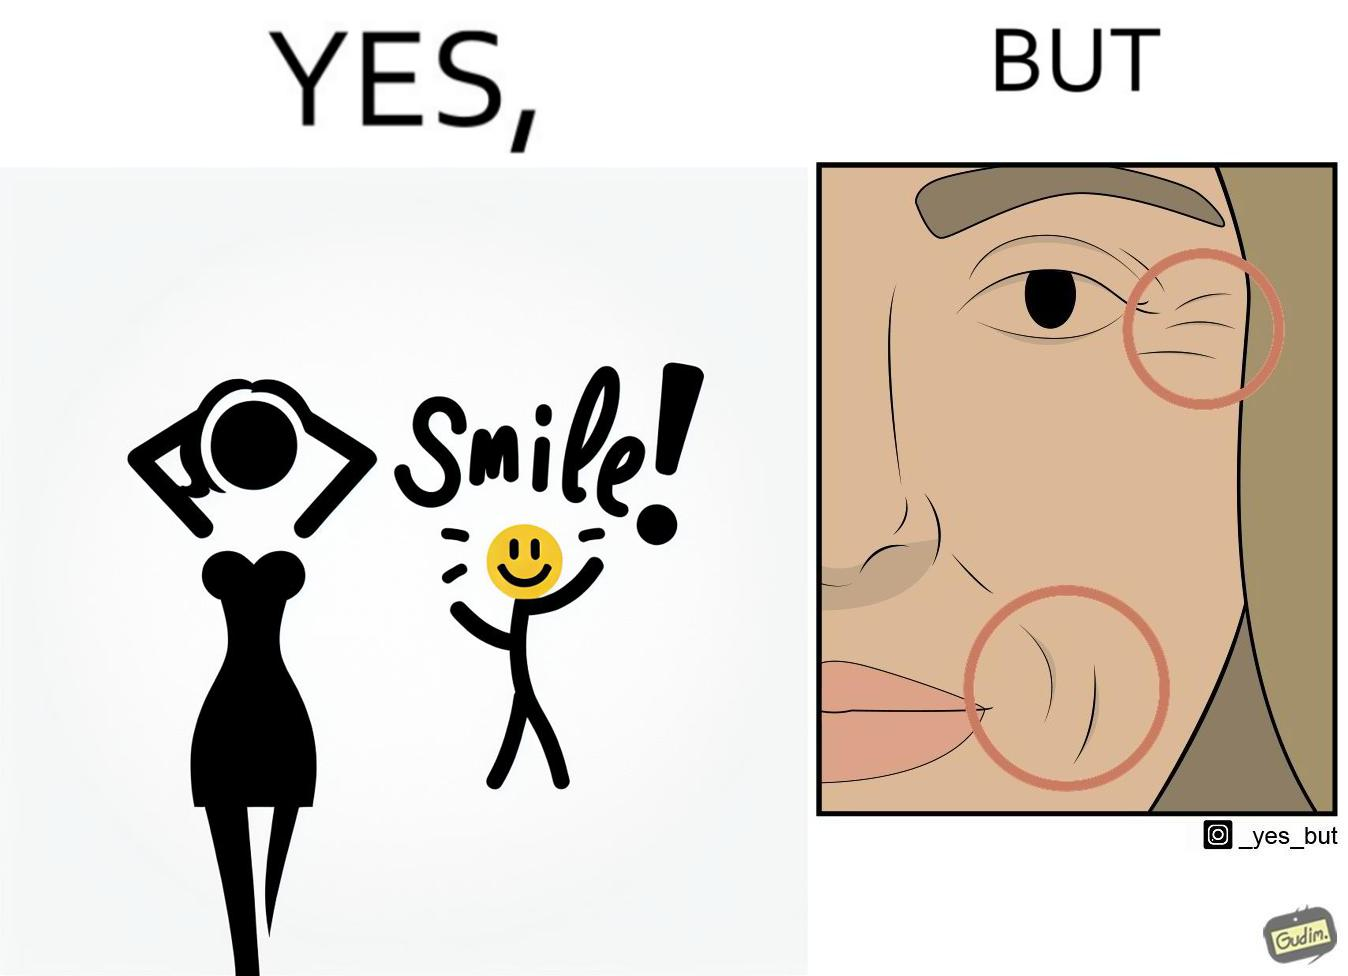Describe the content of this image. The image is ironical because while it suggests people to smile it also shows the wrinkles that can be caused around lips and eyes because of smiling 